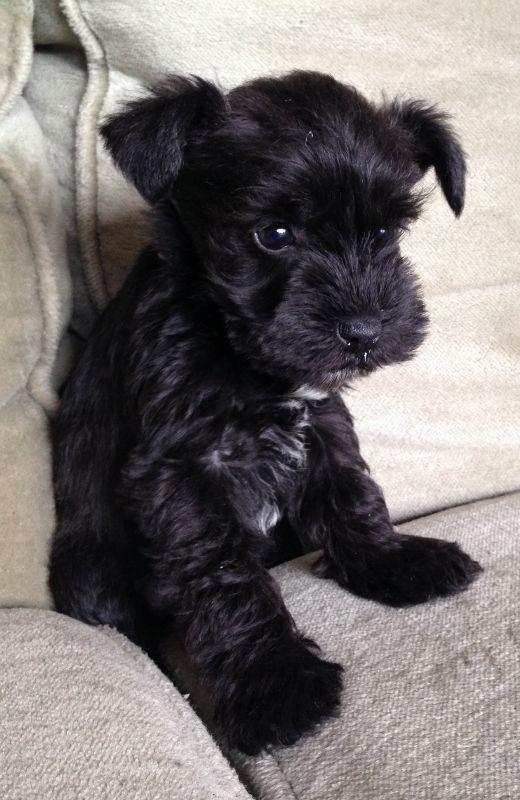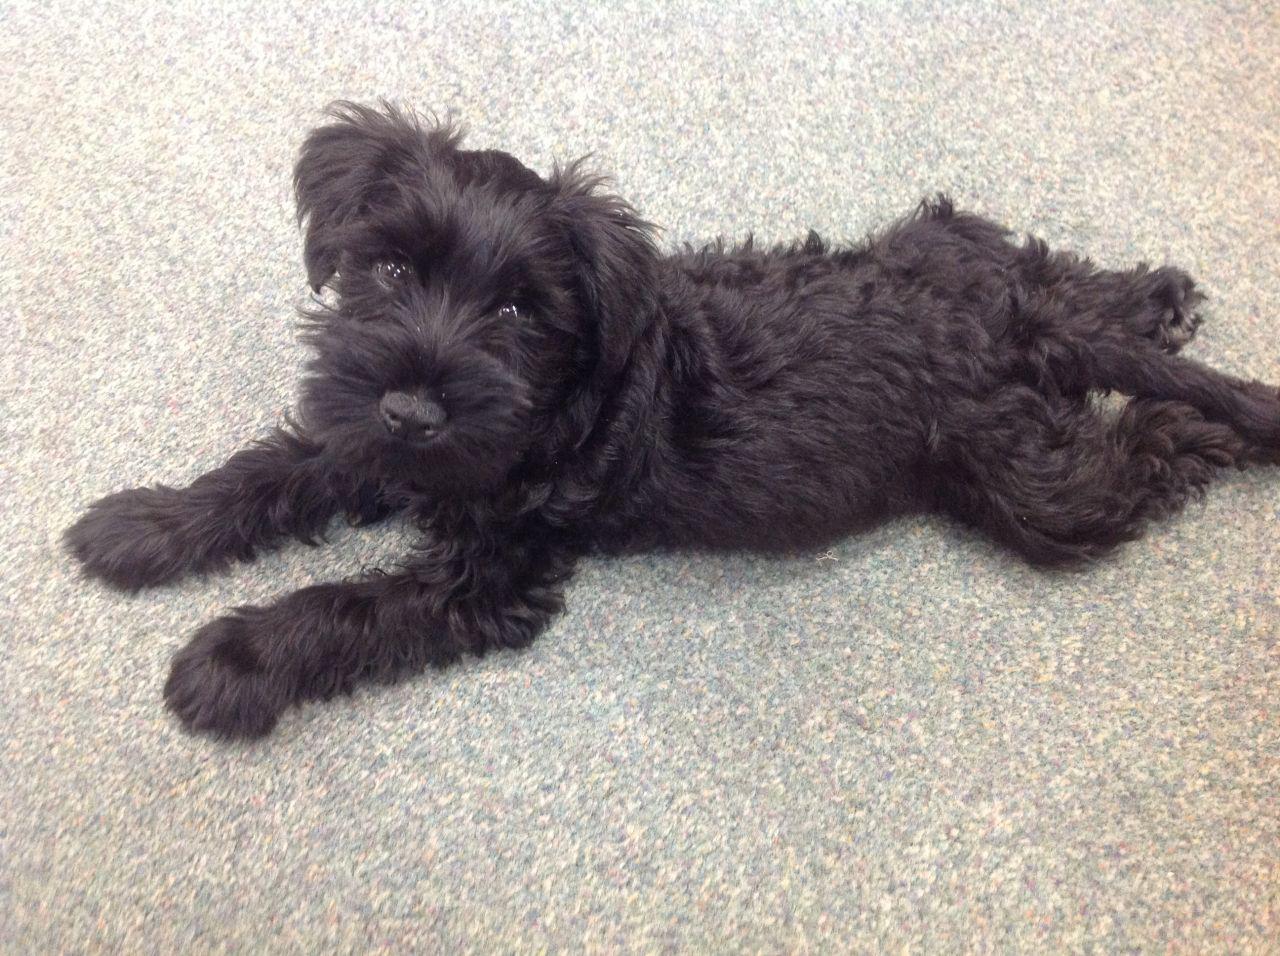The first image is the image on the left, the second image is the image on the right. Analyze the images presented: Is the assertion "The puppy on the right has a white streak on its chest." valid? Answer yes or no. No. The first image is the image on the left, the second image is the image on the right. Considering the images on both sides, is "Each image contains a camera-facing schnauzer with a solid-black face, and no image shows a dog in a reclining pose." valid? Answer yes or no. No. 